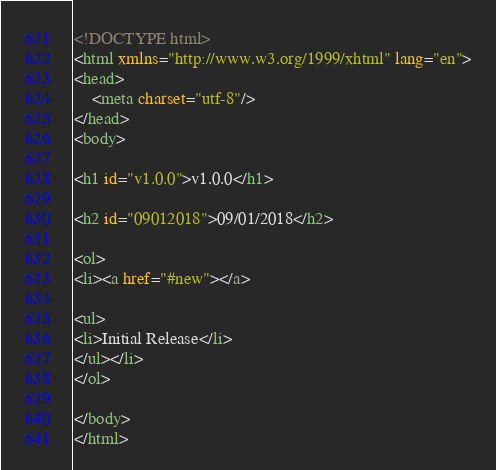Convert code to text. <code><loc_0><loc_0><loc_500><loc_500><_HTML_><!DOCTYPE html>
<html xmlns="http://www.w3.org/1999/xhtml" lang="en">
<head>
	<meta charset="utf-8"/>
</head>
<body>

<h1 id="v1.0.0">v1.0.0</h1>

<h2 id="09012018">09/01/2018</h2>

<ol>
<li><a href="#new"></a>

<ul>
<li>Initial Release</li>
</ul></li>
</ol>

</body>
</html>

</code> 